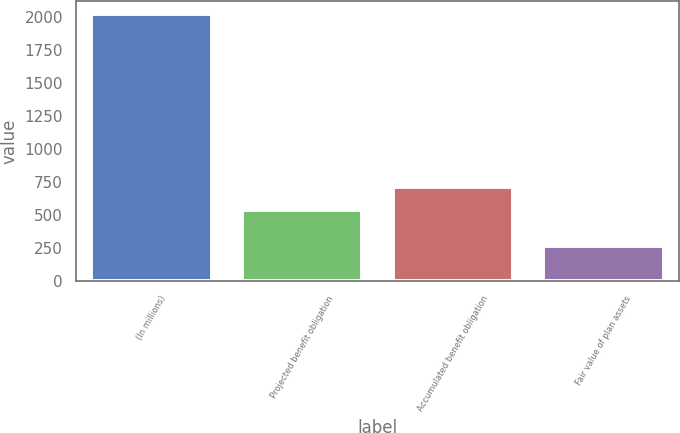Convert chart. <chart><loc_0><loc_0><loc_500><loc_500><bar_chart><fcel>(In millions)<fcel>Projected benefit obligation<fcel>Accumulated benefit obligation<fcel>Fair value of plan assets<nl><fcel>2016<fcel>535<fcel>710.4<fcel>262<nl></chart> 